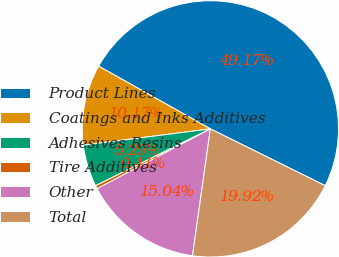<chart> <loc_0><loc_0><loc_500><loc_500><pie_chart><fcel>Product Lines<fcel>Coatings and Inks Additives<fcel>Adhesives Resins<fcel>Tire Additives<fcel>Other<fcel>Total<nl><fcel>49.17%<fcel>10.17%<fcel>5.29%<fcel>0.41%<fcel>15.04%<fcel>19.92%<nl></chart> 